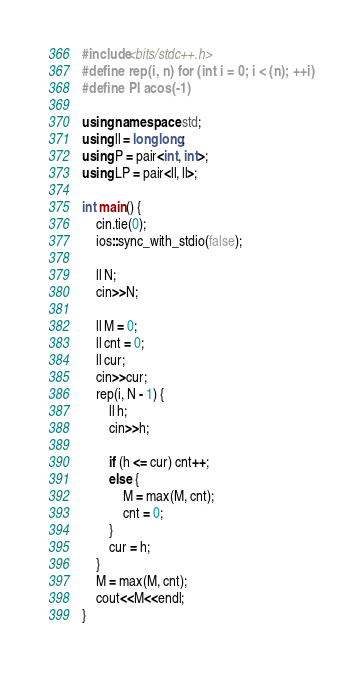Convert code to text. <code><loc_0><loc_0><loc_500><loc_500><_C++_>#include<bits/stdc++.h>
#define rep(i, n) for (int i = 0; i < (n); ++i) 
#define PI acos(-1)

using namespace std;
using ll = long long;
using P = pair<int, int>;
using LP = pair<ll, ll>;

int main() {
    cin.tie(0);
    ios::sync_with_stdio(false);

    ll N;
    cin>>N;

    ll M = 0;
    ll cnt = 0;
    ll cur;
    cin>>cur;
    rep(i, N - 1) {
        ll h;
        cin>>h;

        if (h <= cur) cnt++;
        else {
            M = max(M, cnt);
            cnt = 0;
        }
        cur = h;
    }
    M = max(M, cnt);
    cout<<M<<endl;
}</code> 